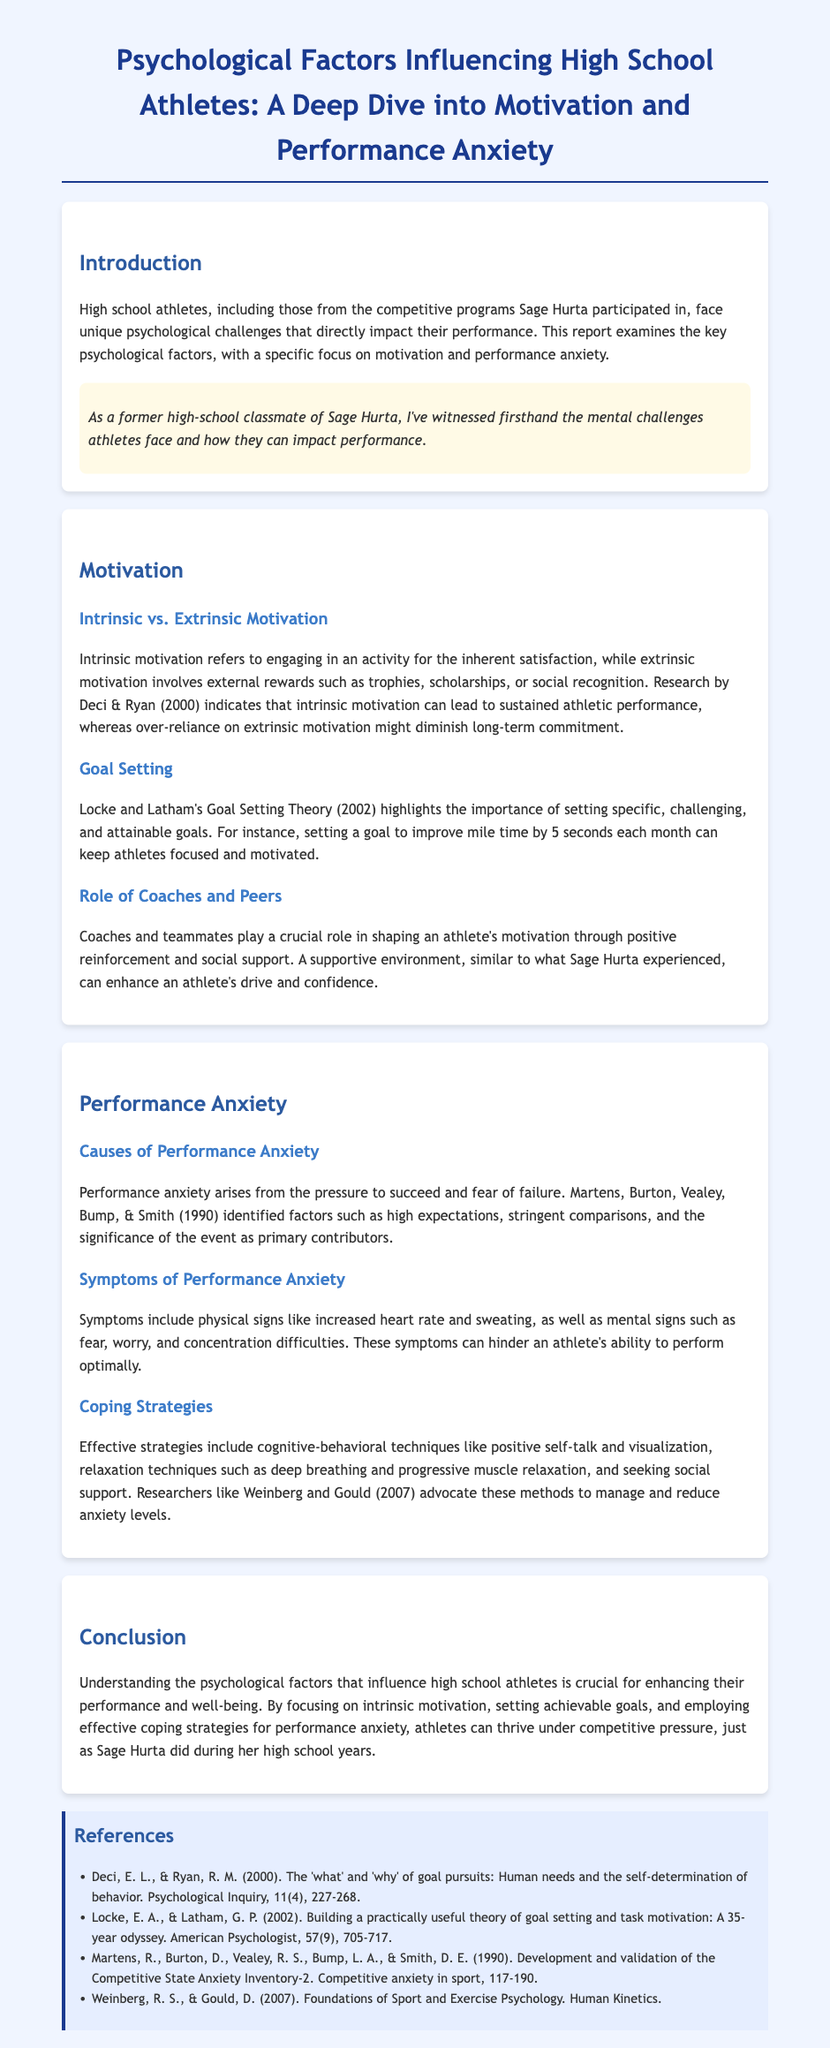what is the main focus of the report? The report examines the key psychological factors, specifically motivation and performance anxiety.
Answer: motivation and performance anxiety who conducted research on intrinsic motivation? Deci & Ryan are the authors cited regarding intrinsic motivation research in the document.
Answer: Deci & Ryan what is one coping strategy mentioned for performance anxiety? The document highlights cognitive-behavioral techniques like positive self-talk as a coping strategy.
Answer: positive self-talk how many symptoms of performance anxiety are mentioned? The document lists physical and mental signs as symptoms, specifically naming at least two of each.
Answer: four who's experience is referenced regarding motivational support in athletics? The report mentions Sage Hurta's experiences to illustrate the positive role of coaches and peers.
Answer: Sage Hurta what is the primary contributor to performance anxiety according to Martens et al.? The document states that high expectations are primary contributors to performance anxiety.
Answer: high expectations what type of goals does Locke and Latham's Goal Setting Theory emphasize? The theory emphasizes setting specific, challenging, and attainable goals.
Answer: specific, challenging, and attainable which year was the Competitive State Anxiety Inventory-2 developed? The development and validation are referenced in the year 1990.
Answer: 1990 what psychological aspect is emphasized in the conclusion for high school athletes? The conclusion highlights understanding psychological factors to enhance performance and well-being.
Answer: psychological factors 